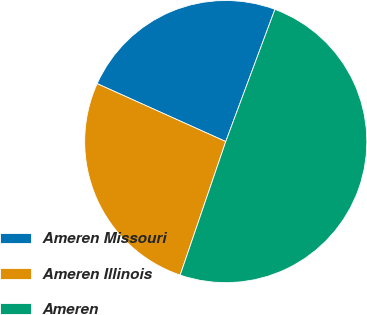Convert chart. <chart><loc_0><loc_0><loc_500><loc_500><pie_chart><fcel>Ameren Missouri<fcel>Ameren Illinois<fcel>Ameren<nl><fcel>23.93%<fcel>26.5%<fcel>49.57%<nl></chart> 